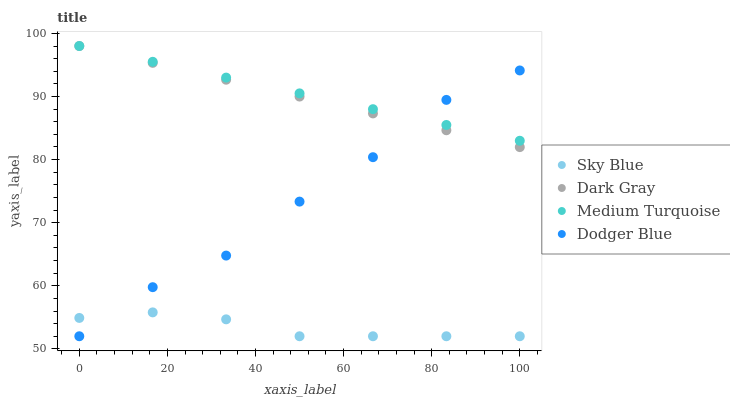Does Sky Blue have the minimum area under the curve?
Answer yes or no. Yes. Does Medium Turquoise have the maximum area under the curve?
Answer yes or no. Yes. Does Dodger Blue have the minimum area under the curve?
Answer yes or no. No. Does Dodger Blue have the maximum area under the curve?
Answer yes or no. No. Is Medium Turquoise the smoothest?
Answer yes or no. Yes. Is Dodger Blue the roughest?
Answer yes or no. Yes. Is Sky Blue the smoothest?
Answer yes or no. No. Is Sky Blue the roughest?
Answer yes or no. No. Does Sky Blue have the lowest value?
Answer yes or no. Yes. Does Medium Turquoise have the lowest value?
Answer yes or no. No. Does Medium Turquoise have the highest value?
Answer yes or no. Yes. Does Dodger Blue have the highest value?
Answer yes or no. No. Is Sky Blue less than Medium Turquoise?
Answer yes or no. Yes. Is Medium Turquoise greater than Sky Blue?
Answer yes or no. Yes. Does Medium Turquoise intersect Dodger Blue?
Answer yes or no. Yes. Is Medium Turquoise less than Dodger Blue?
Answer yes or no. No. Is Medium Turquoise greater than Dodger Blue?
Answer yes or no. No. Does Sky Blue intersect Medium Turquoise?
Answer yes or no. No. 